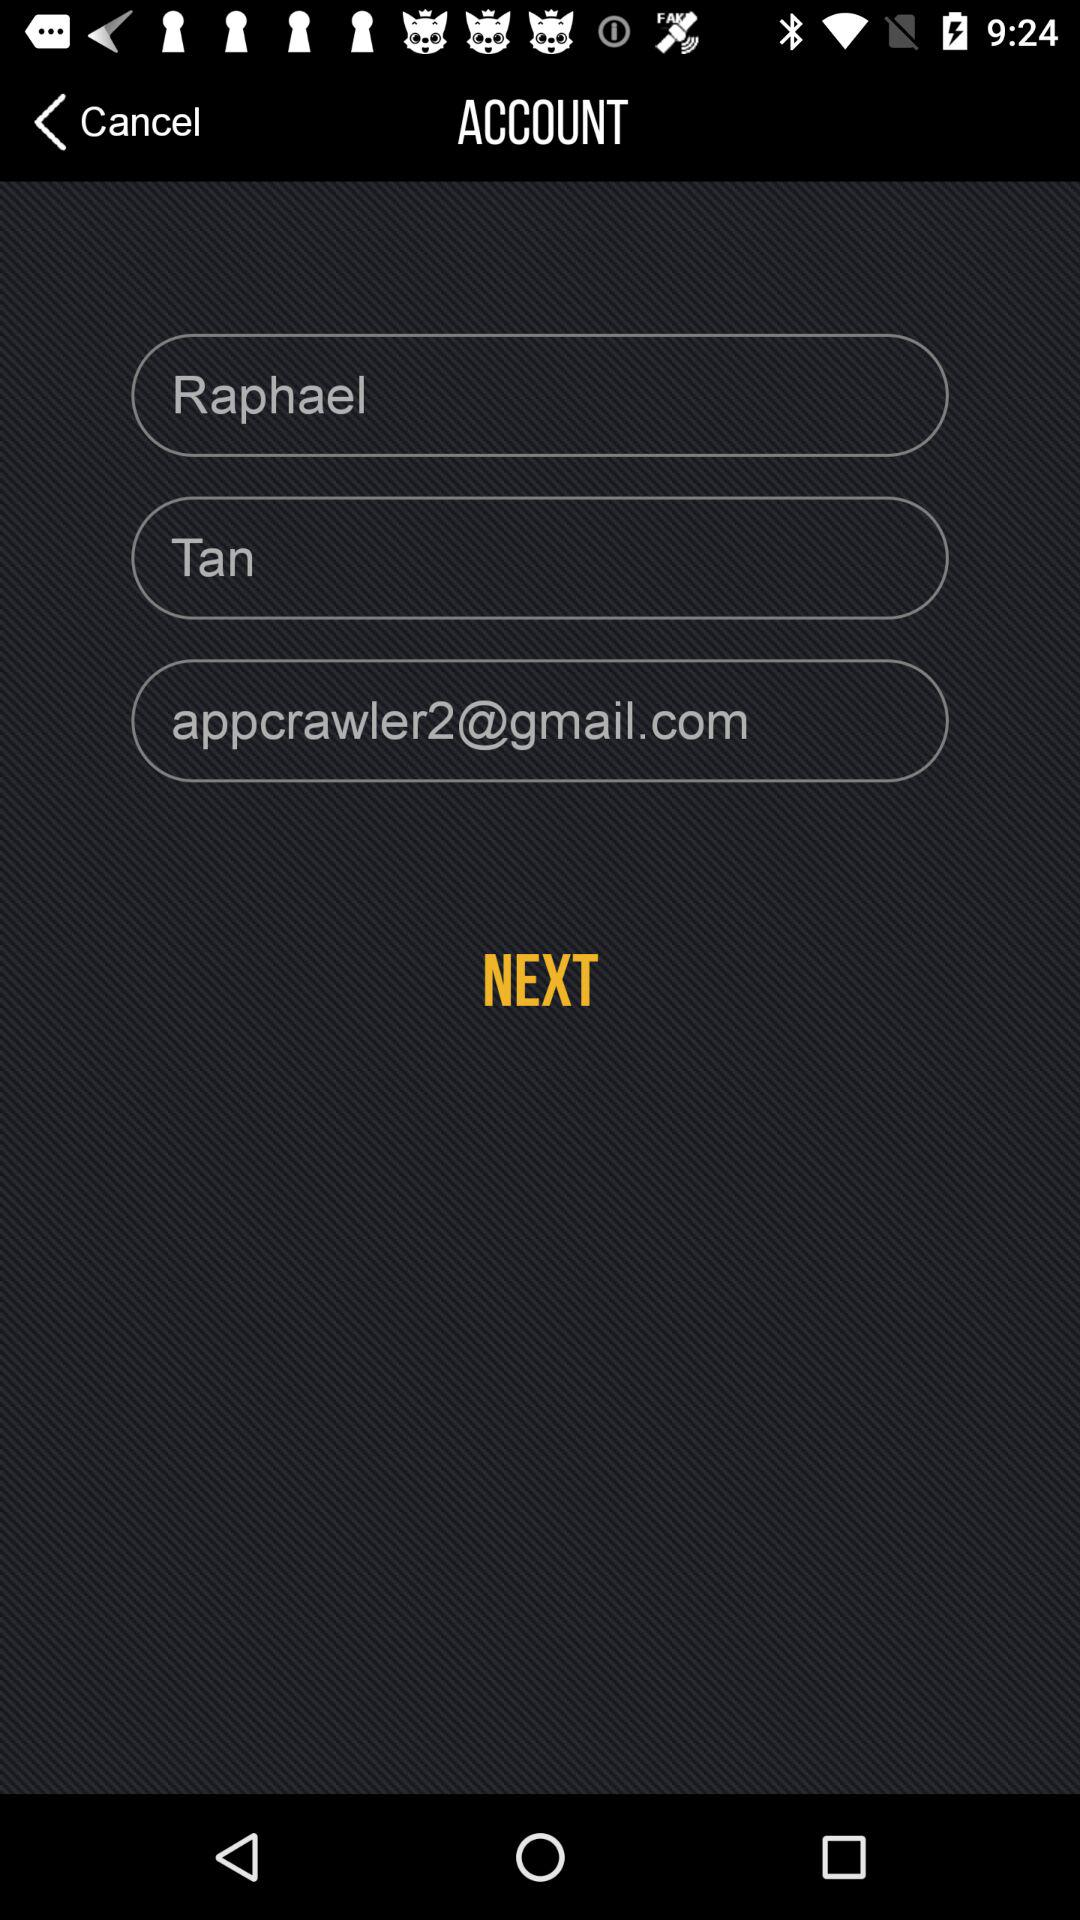What is the user name? The user name is Raphael Tan. 